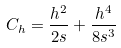Convert formula to latex. <formula><loc_0><loc_0><loc_500><loc_500>C _ { h } = \frac { h ^ { 2 } } { 2 s } + \frac { h ^ { 4 } } { 8 s ^ { 3 } }</formula> 